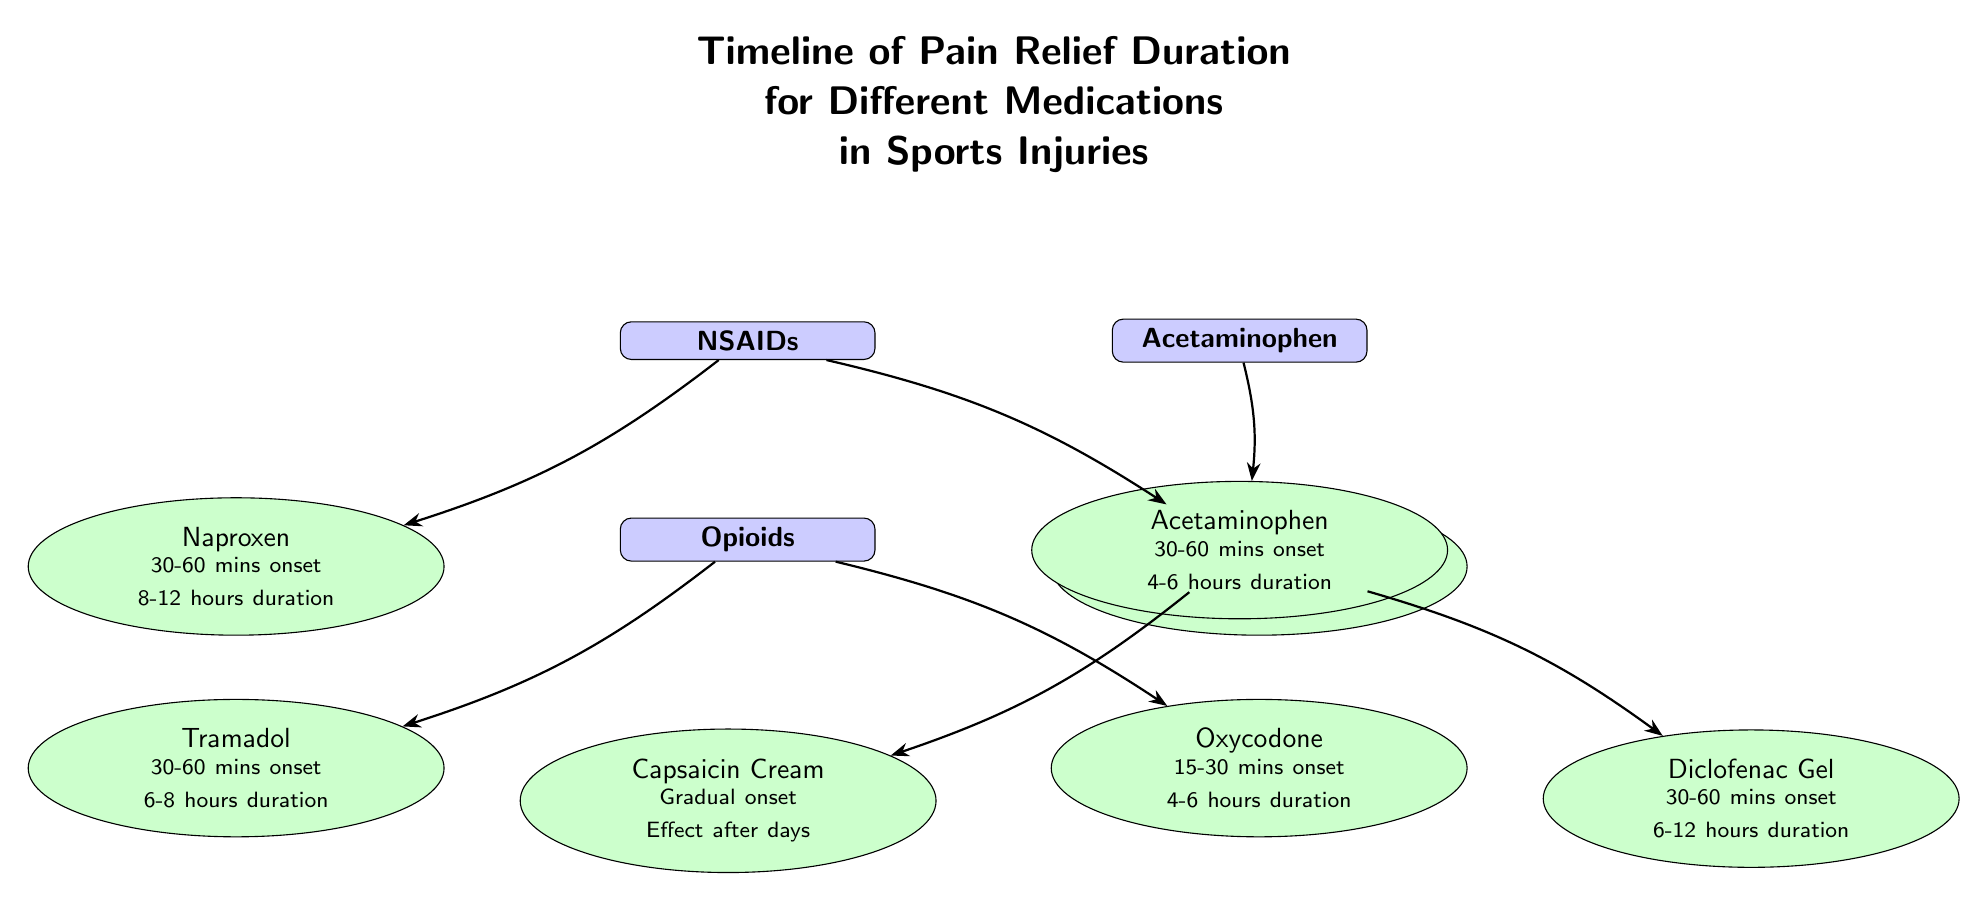What is the duration of pain relief for Ibuprofen? According to the diagram, Ibuprofen has a duration of pain relief lasting 4-6 hours, which is stated directly next to its label.
Answer: 4-6 hours How many categories of medications are shown? The diagram presents four categories: NSAIDs, Acetaminophen, Opioids, and Topical Treatments. Therefore, by counting the categories displayed, we find there are four.
Answer: 4 What is the onset time for Oxycodone? The diagram indicates that Oxycodone has an onset time of 15-30 minutes, which can be found below its medication label.
Answer: 15-30 minutes Which medication provides a gradual onset effect? The diagram specifies Capsaicin Cream as the medication with a gradual onset effect, as indicated by the description next to its label in the topical treatments category.
Answer: Capsaicin Cream What is the longest duration of pain relief among the medications listed? By comparing the stated durations for all medications, Naproxen offers the longest duration of 8-12 hours. This is found in the description next to its label in the NSAIDs category, making it the longest duration among the options.
Answer: 8-12 hours Which type of medication has the shortest onset time? The diagram reveals that Oxycodone has the shortest onset time of 15-30 minutes, as indicated among the other medications listed, specifically within the Opioids category.
Answer: Oxycodone Which topical medication offers pain relief for up to 12 hours? The pain relief duration for Diclofenac Gel is specified as 6-12 hours, making it the topical medication that can last up to 12 hours, and this information is outlined clearly next to its label.
Answer: Diclofenac Gel How many medications are listed under Opioids? There are two medications listed under the Opioids category: Oxycodone and Tramadol. By counting the medications in this section of the diagram, we conclude there are two.
Answer: 2 What is the relationship between NSAIDs and Ibuprofen? The diagram directly connects NSAIDs to the Ibuprofen medication node with an arrow, showing that Ibuprofen falls under the category of NSAIDs. This relationship is visually represented by the arrow drawn from the NSAIDs category to the Ibuprofen label.
Answer: Under the category of NSAIDs 